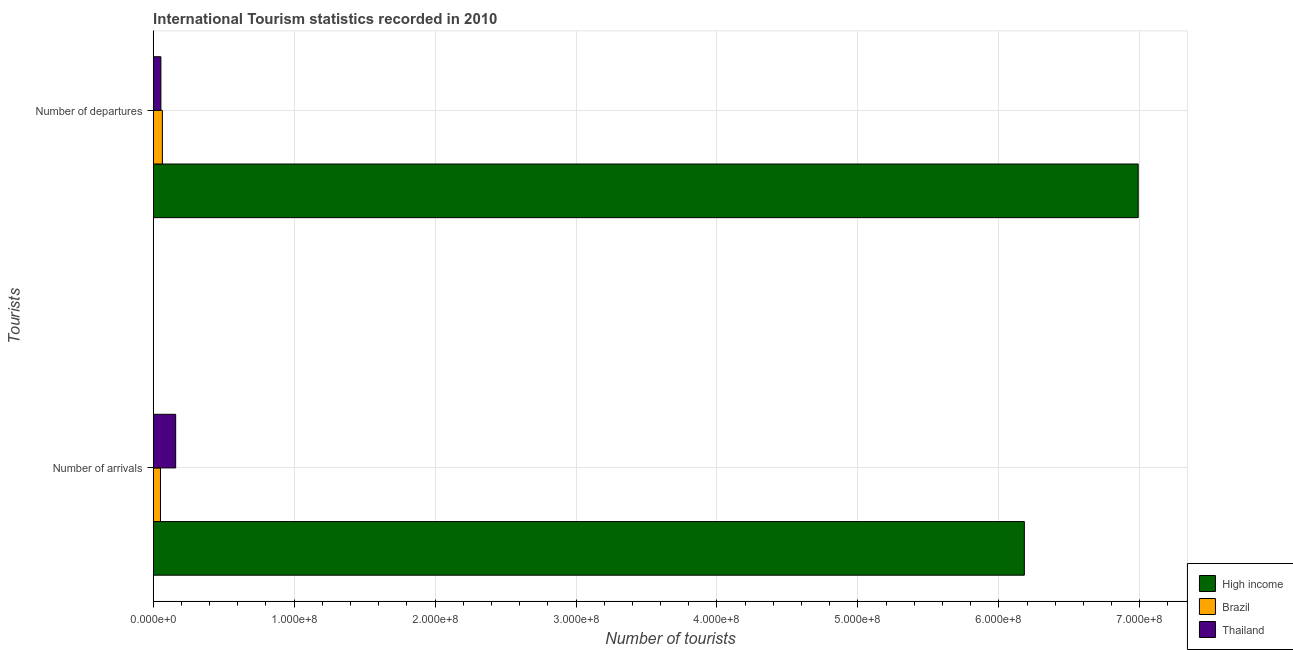How many different coloured bars are there?
Keep it short and to the point. 3. How many groups of bars are there?
Your response must be concise. 2. How many bars are there on the 1st tick from the top?
Provide a short and direct response. 3. What is the label of the 2nd group of bars from the top?
Your answer should be compact. Number of arrivals. What is the number of tourist departures in High income?
Make the answer very short. 6.99e+08. Across all countries, what is the maximum number of tourist departures?
Make the answer very short. 6.99e+08. Across all countries, what is the minimum number of tourist departures?
Your answer should be very brief. 5.45e+06. In which country was the number of tourist departures minimum?
Offer a terse response. Thailand. What is the total number of tourist arrivals in the graph?
Provide a short and direct response. 6.39e+08. What is the difference between the number of tourist arrivals in High income and that in Brazil?
Offer a very short reply. 6.13e+08. What is the difference between the number of tourist departures in High income and the number of tourist arrivals in Thailand?
Give a very brief answer. 6.83e+08. What is the average number of tourist arrivals per country?
Give a very brief answer. 2.13e+08. What is the difference between the number of tourist arrivals and number of tourist departures in Brazil?
Ensure brevity in your answer.  -1.34e+06. In how many countries, is the number of tourist departures greater than 400000000 ?
Offer a very short reply. 1. What is the ratio of the number of tourist arrivals in Brazil to that in High income?
Offer a terse response. 0.01. In how many countries, is the number of tourist arrivals greater than the average number of tourist arrivals taken over all countries?
Provide a succinct answer. 1. What does the 1st bar from the top in Number of arrivals represents?
Provide a succinct answer. Thailand. What does the 2nd bar from the bottom in Number of departures represents?
Your answer should be compact. Brazil. How many bars are there?
Your answer should be compact. 6. How many countries are there in the graph?
Give a very brief answer. 3. What is the difference between two consecutive major ticks on the X-axis?
Your answer should be compact. 1.00e+08. Where does the legend appear in the graph?
Your answer should be compact. Bottom right. How many legend labels are there?
Make the answer very short. 3. What is the title of the graph?
Ensure brevity in your answer.  International Tourism statistics recorded in 2010. Does "Latin America(all income levels)" appear as one of the legend labels in the graph?
Give a very brief answer. No. What is the label or title of the X-axis?
Offer a very short reply. Number of tourists. What is the label or title of the Y-axis?
Give a very brief answer. Tourists. What is the Number of tourists in High income in Number of arrivals?
Your answer should be compact. 6.18e+08. What is the Number of tourists in Brazil in Number of arrivals?
Your answer should be compact. 5.16e+06. What is the Number of tourists in Thailand in Number of arrivals?
Ensure brevity in your answer.  1.59e+07. What is the Number of tourists in High income in Number of departures?
Offer a very short reply. 6.99e+08. What is the Number of tourists in Brazil in Number of departures?
Your response must be concise. 6.50e+06. What is the Number of tourists of Thailand in Number of departures?
Give a very brief answer. 5.45e+06. Across all Tourists, what is the maximum Number of tourists in High income?
Ensure brevity in your answer.  6.99e+08. Across all Tourists, what is the maximum Number of tourists of Brazil?
Your answer should be compact. 6.50e+06. Across all Tourists, what is the maximum Number of tourists in Thailand?
Offer a terse response. 1.59e+07. Across all Tourists, what is the minimum Number of tourists in High income?
Keep it short and to the point. 6.18e+08. Across all Tourists, what is the minimum Number of tourists in Brazil?
Give a very brief answer. 5.16e+06. Across all Tourists, what is the minimum Number of tourists of Thailand?
Ensure brevity in your answer.  5.45e+06. What is the total Number of tourists of High income in the graph?
Offer a terse response. 1.32e+09. What is the total Number of tourists in Brazil in the graph?
Provide a succinct answer. 1.17e+07. What is the total Number of tourists in Thailand in the graph?
Your answer should be very brief. 2.14e+07. What is the difference between the Number of tourists in High income in Number of arrivals and that in Number of departures?
Your answer should be compact. -8.08e+07. What is the difference between the Number of tourists of Brazil in Number of arrivals and that in Number of departures?
Ensure brevity in your answer.  -1.34e+06. What is the difference between the Number of tourists in Thailand in Number of arrivals and that in Number of departures?
Give a very brief answer. 1.05e+07. What is the difference between the Number of tourists of High income in Number of arrivals and the Number of tourists of Brazil in Number of departures?
Provide a short and direct response. 6.12e+08. What is the difference between the Number of tourists in High income in Number of arrivals and the Number of tourists in Thailand in Number of departures?
Offer a very short reply. 6.13e+08. What is the average Number of tourists of High income per Tourists?
Ensure brevity in your answer.  6.58e+08. What is the average Number of tourists of Brazil per Tourists?
Offer a terse response. 5.83e+06. What is the average Number of tourists of Thailand per Tourists?
Your answer should be compact. 1.07e+07. What is the difference between the Number of tourists of High income and Number of tourists of Brazil in Number of arrivals?
Ensure brevity in your answer.  6.13e+08. What is the difference between the Number of tourists of High income and Number of tourists of Thailand in Number of arrivals?
Give a very brief answer. 6.02e+08. What is the difference between the Number of tourists in Brazil and Number of tourists in Thailand in Number of arrivals?
Provide a short and direct response. -1.08e+07. What is the difference between the Number of tourists of High income and Number of tourists of Brazil in Number of departures?
Keep it short and to the point. 6.92e+08. What is the difference between the Number of tourists in High income and Number of tourists in Thailand in Number of departures?
Your answer should be compact. 6.93e+08. What is the difference between the Number of tourists of Brazil and Number of tourists of Thailand in Number of departures?
Your answer should be compact. 1.05e+06. What is the ratio of the Number of tourists in High income in Number of arrivals to that in Number of departures?
Keep it short and to the point. 0.88. What is the ratio of the Number of tourists of Brazil in Number of arrivals to that in Number of departures?
Make the answer very short. 0.79. What is the ratio of the Number of tourists of Thailand in Number of arrivals to that in Number of departures?
Offer a very short reply. 2.92. What is the difference between the highest and the second highest Number of tourists of High income?
Your answer should be compact. 8.08e+07. What is the difference between the highest and the second highest Number of tourists of Brazil?
Keep it short and to the point. 1.34e+06. What is the difference between the highest and the second highest Number of tourists in Thailand?
Your answer should be compact. 1.05e+07. What is the difference between the highest and the lowest Number of tourists in High income?
Your response must be concise. 8.08e+07. What is the difference between the highest and the lowest Number of tourists of Brazil?
Offer a terse response. 1.34e+06. What is the difference between the highest and the lowest Number of tourists of Thailand?
Ensure brevity in your answer.  1.05e+07. 